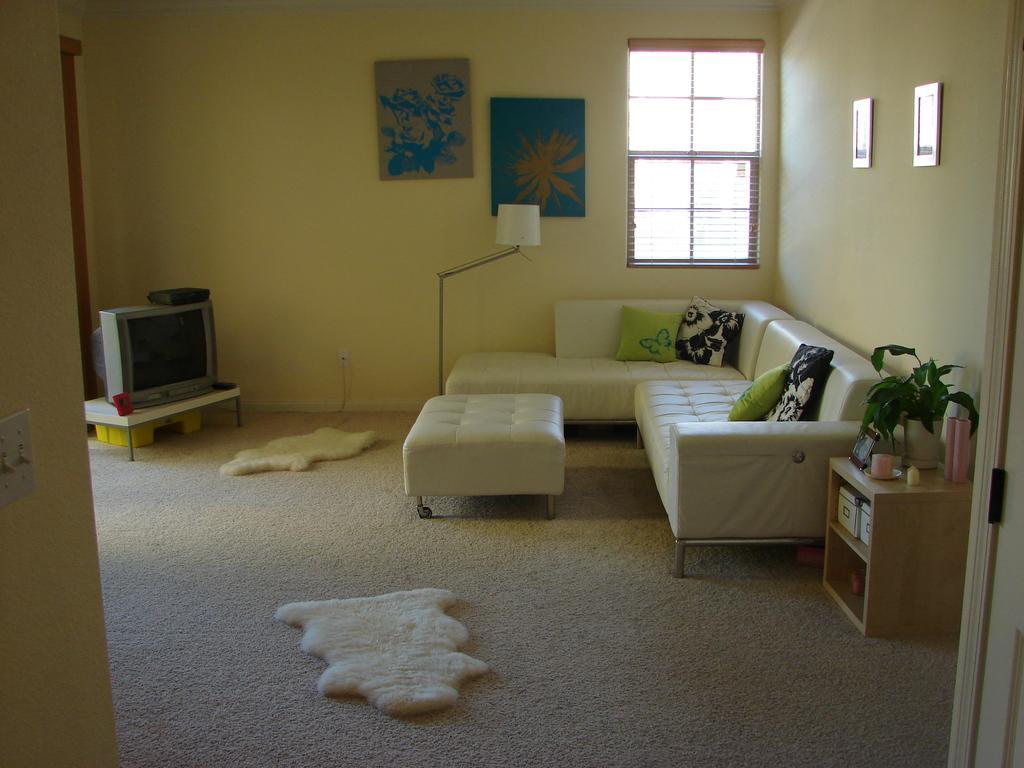How would you summarize this image in a sentence or two? In room to the right side there is a sofa with black and green pillows on it. And on the top of the sofa there is a window. To the right side wall there are two frames. And beside the sofa there is a table with pot and a cup on it. On the floor there are two floor mats. And to the left corner there is a television on the table. There is a door and two frames in the middle of the wall. 